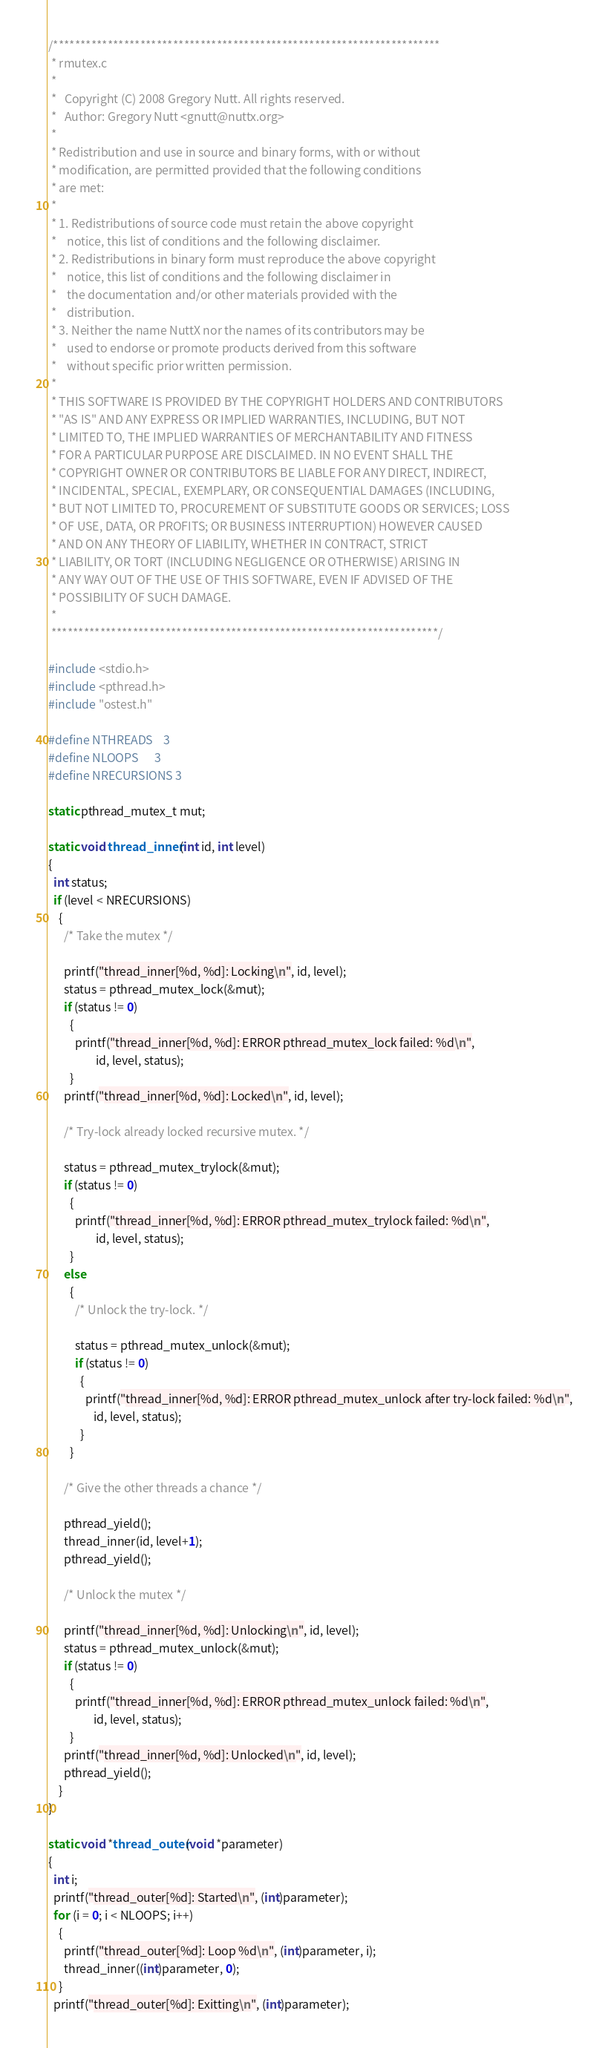<code> <loc_0><loc_0><loc_500><loc_500><_C_>/***********************************************************************
 * rmutex.c
 *
 *   Copyright (C) 2008 Gregory Nutt. All rights reserved.
 *   Author: Gregory Nutt <gnutt@nuttx.org>
 *
 * Redistribution and use in source and binary forms, with or without
 * modification, are permitted provided that the following conditions
 * are met:
 *
 * 1. Redistributions of source code must retain the above copyright
 *    notice, this list of conditions and the following disclaimer.
 * 2. Redistributions in binary form must reproduce the above copyright
 *    notice, this list of conditions and the following disclaimer in
 *    the documentation and/or other materials provided with the
 *    distribution.
 * 3. Neither the name NuttX nor the names of its contributors may be
 *    used to endorse or promote products derived from this software
 *    without specific prior written permission.
 *
 * THIS SOFTWARE IS PROVIDED BY THE COPYRIGHT HOLDERS AND CONTRIBUTORS
 * "AS IS" AND ANY EXPRESS OR IMPLIED WARRANTIES, INCLUDING, BUT NOT
 * LIMITED TO, THE IMPLIED WARRANTIES OF MERCHANTABILITY AND FITNESS
 * FOR A PARTICULAR PURPOSE ARE DISCLAIMED. IN NO EVENT SHALL THE
 * COPYRIGHT OWNER OR CONTRIBUTORS BE LIABLE FOR ANY DIRECT, INDIRECT,
 * INCIDENTAL, SPECIAL, EXEMPLARY, OR CONSEQUENTIAL DAMAGES (INCLUDING,
 * BUT NOT LIMITED TO, PROCUREMENT OF SUBSTITUTE GOODS OR SERVICES; LOSS
 * OF USE, DATA, OR PROFITS; OR BUSINESS INTERRUPTION) HOWEVER CAUSED
 * AND ON ANY THEORY OF LIABILITY, WHETHER IN CONTRACT, STRICT
 * LIABILITY, OR TORT (INCLUDING NEGLIGENCE OR OTHERWISE) ARISING IN
 * ANY WAY OUT OF THE USE OF THIS SOFTWARE, EVEN IF ADVISED OF THE
 * POSSIBILITY OF SUCH DAMAGE.
 *
 ***********************************************************************/

#include <stdio.h>
#include <pthread.h>
#include "ostest.h"

#define NTHREADS    3
#define NLOOPS      3
#define NRECURSIONS 3

static pthread_mutex_t mut;

static void thread_inner(int id, int level)
{
  int status;
  if (level < NRECURSIONS)
    {
      /* Take the mutex */

      printf("thread_inner[%d, %d]: Locking\n", id, level);
      status = pthread_mutex_lock(&mut);
      if (status != 0)
        {
          printf("thread_inner[%d, %d]: ERROR pthread_mutex_lock failed: %d\n",
                  id, level, status);
        }
      printf("thread_inner[%d, %d]: Locked\n", id, level);

      /* Try-lock already locked recursive mutex. */

      status = pthread_mutex_trylock(&mut);
      if (status != 0)
        {
          printf("thread_inner[%d, %d]: ERROR pthread_mutex_trylock failed: %d\n",
                  id, level, status);
        }
      else
        {
          /* Unlock the try-lock. */

          status = pthread_mutex_unlock(&mut);
          if (status != 0)
            {
              printf("thread_inner[%d, %d]: ERROR pthread_mutex_unlock after try-lock failed: %d\n",
                 id, level, status);
            }
        }

      /* Give the other threads a chance */

      pthread_yield();
      thread_inner(id, level+1);
      pthread_yield();

      /* Unlock the mutex */

      printf("thread_inner[%d, %d]: Unlocking\n", id, level);
      status = pthread_mutex_unlock(&mut);
      if (status != 0)
        {
          printf("thread_inner[%d, %d]: ERROR pthread_mutex_unlock failed: %d\n",
                 id, level, status);
        }
      printf("thread_inner[%d, %d]: Unlocked\n", id, level);
      pthread_yield();
    }
}

static void *thread_outer(void *parameter)
{
  int i;
  printf("thread_outer[%d]: Started\n", (int)parameter);
  for (i = 0; i < NLOOPS; i++)
    {
      printf("thread_outer[%d]: Loop %d\n", (int)parameter, i);
      thread_inner((int)parameter, 0);
    }
  printf("thread_outer[%d]: Exitting\n", (int)parameter);</code> 